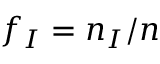Convert formula to latex. <formula><loc_0><loc_0><loc_500><loc_500>f _ { I } = n _ { I } / n</formula> 